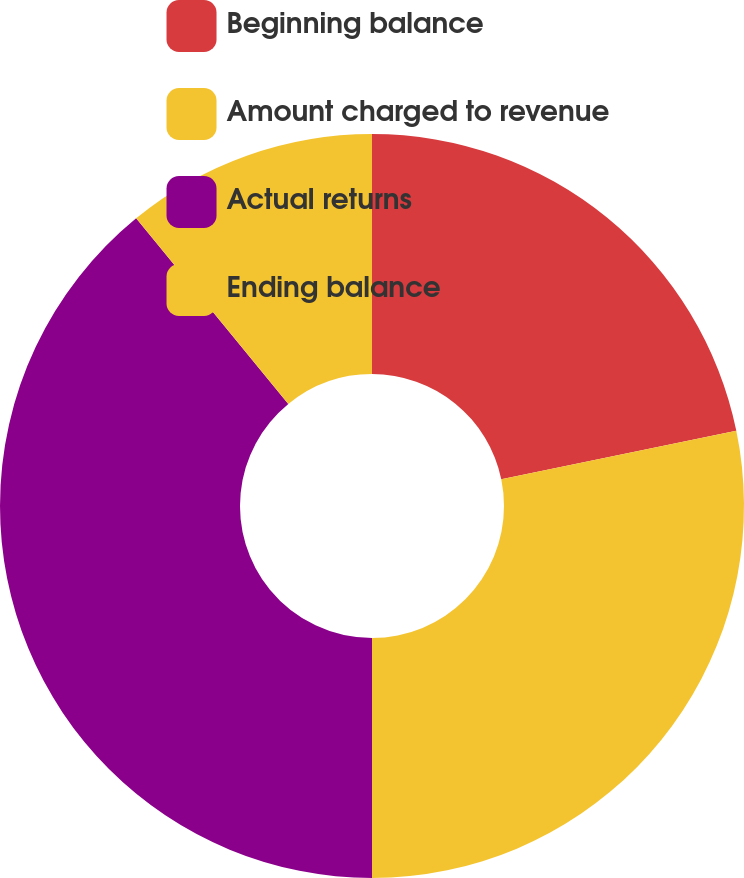Convert chart to OTSL. <chart><loc_0><loc_0><loc_500><loc_500><pie_chart><fcel>Beginning balance<fcel>Amount charged to revenue<fcel>Actual returns<fcel>Ending balance<nl><fcel>21.76%<fcel>28.24%<fcel>39.07%<fcel>10.93%<nl></chart> 